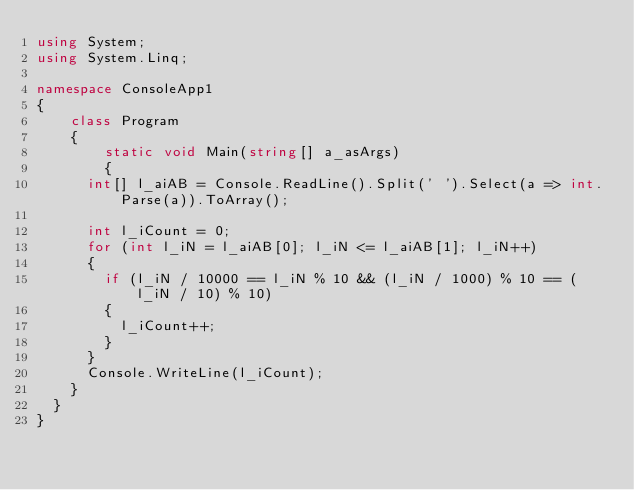<code> <loc_0><loc_0><loc_500><loc_500><_C#_>using System;
using System.Linq;

namespace ConsoleApp1
{
    class Program
    {
        static void Main(string[] a_asArgs)
        {
			int[] l_aiAB = Console.ReadLine().Split(' ').Select(a => int.Parse(a)).ToArray();

			int l_iCount = 0;
			for (int l_iN = l_aiAB[0]; l_iN <= l_aiAB[1]; l_iN++)
			{
				if (l_iN / 10000 == l_iN % 10 && (l_iN / 1000) % 10 == (l_iN / 10) % 10)
				{
					l_iCount++;
				}
			}
			Console.WriteLine(l_iCount);
		}
	}
}
</code> 